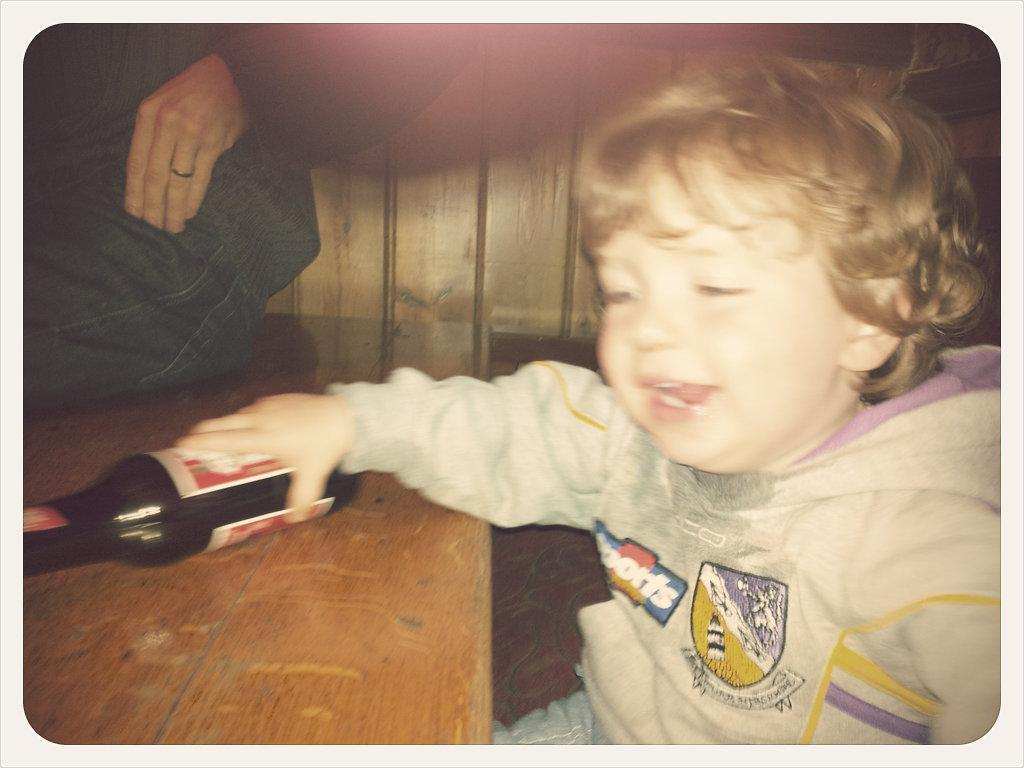Who is the main subject in the image? There is a boy in the image. What is the boy wearing? The boy is wearing a white dress. What is the boy holding in the image? The boy is holding a bottle. Where is the bottle located? The bottle is on a table. What is the position of the person in the image? There is a person sitting on the table. What type of juice is being served in the quarter-sized glass in the image? There is no glass or juice present in the image; it features a boy holding a bottle on a table with a person sitting on it. 